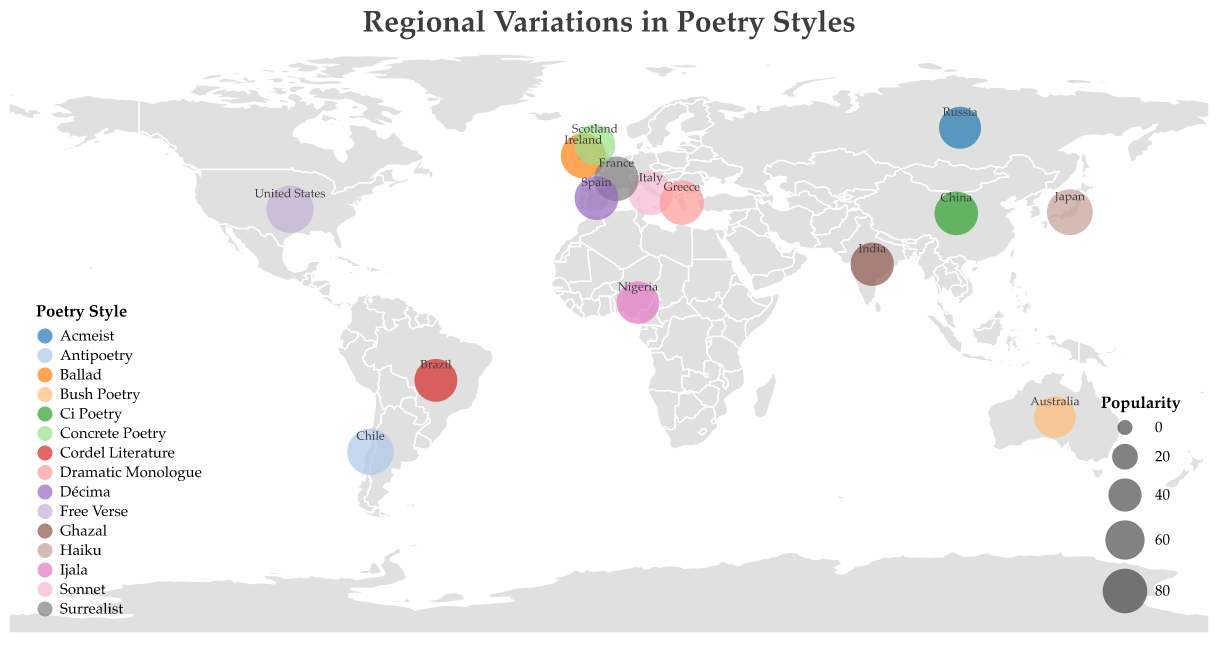What is the most popular poetry style according to the figure? The United States' Free Verse has the highest popularity value on the plot, which is 92.
Answer: Free Verse How many regions have a poetry style with a popularity rating above 80? To find this, evaluate each region's popularity rating: Japan (85), United States (92), Italy (78), Russia (70), Chile (88), Ireland (82), China (76), France (80), Nigeria (72), Australia (68), India (75), Scotland (65), Brazil (73), Spain (77), Greece (79). Regions with a rating above 80 are Japan, United States, Chile, Ireland, and France, totaling 5 regions.
Answer: 5 Which region's poetry style is least popular? Australia's Bush Poetry has the lowest popularity rating of 68.
Answer: Australia What distinctive feature characterizes the most popular poetry style? The most popular poetry style is Free Verse from the United States, characterized by "Experimental language."
Answer: Experimental language Compare the popularity of Haiku from Japan to Ci Poetry from China. Which one is more popular and by how much? Haiku has a popularity of 85, and Ci Poetry has a popularity of 76. The difference is 85 - 76 = 9, so Haiku is more popular by 9 points.
Answer: Haiku by 9 points Which regions have poetry styles that emphasize imagery? The regions and their respective styles with emphasis on imagery are Japan with Haiku (Concise nature imagery) and France with Surrealist poetry (Dreamlike imagery).
Answer: Japan and France What is the average popularity of the poetry styles from Europe? Europe includes Italy (78), Russia (70), Ireland (82), France (80), Scotland (65), Spain (77), and Greece (79). The average is calculated as (78 + 70 + 82 + 80 + 65 + 77 + 79) / 7 = 531 / 7 ≈ 75.86.
Answer: 75.86 Identify the style of poetry characterized by "Narrative storytelling" and its popularity rating. The style characterized by "Narrative storytelling" is the Ballad from Ireland, which has a popularity rating of 82.
Answer: Ballad, 82 Which regions have poetry styles directly labeled on the map, and what are these styles? The regions with labeled poetry styles are Japan (Haiku), United States (Free Verse), Italy (Sonnet), Russia (Acmeist), Chile (Antipoetry), Ireland (Ballad), China (Ci Poetry), France (Surrealist), Nigeria (Ijala), Australia (Bush Poetry), India (Ghazal), Scotland (Concrete Poetry), Brazil (Cordel Literature), Spain (Décima), and Greece (Dramatic Monologue).
Answer: All regions on the plot 